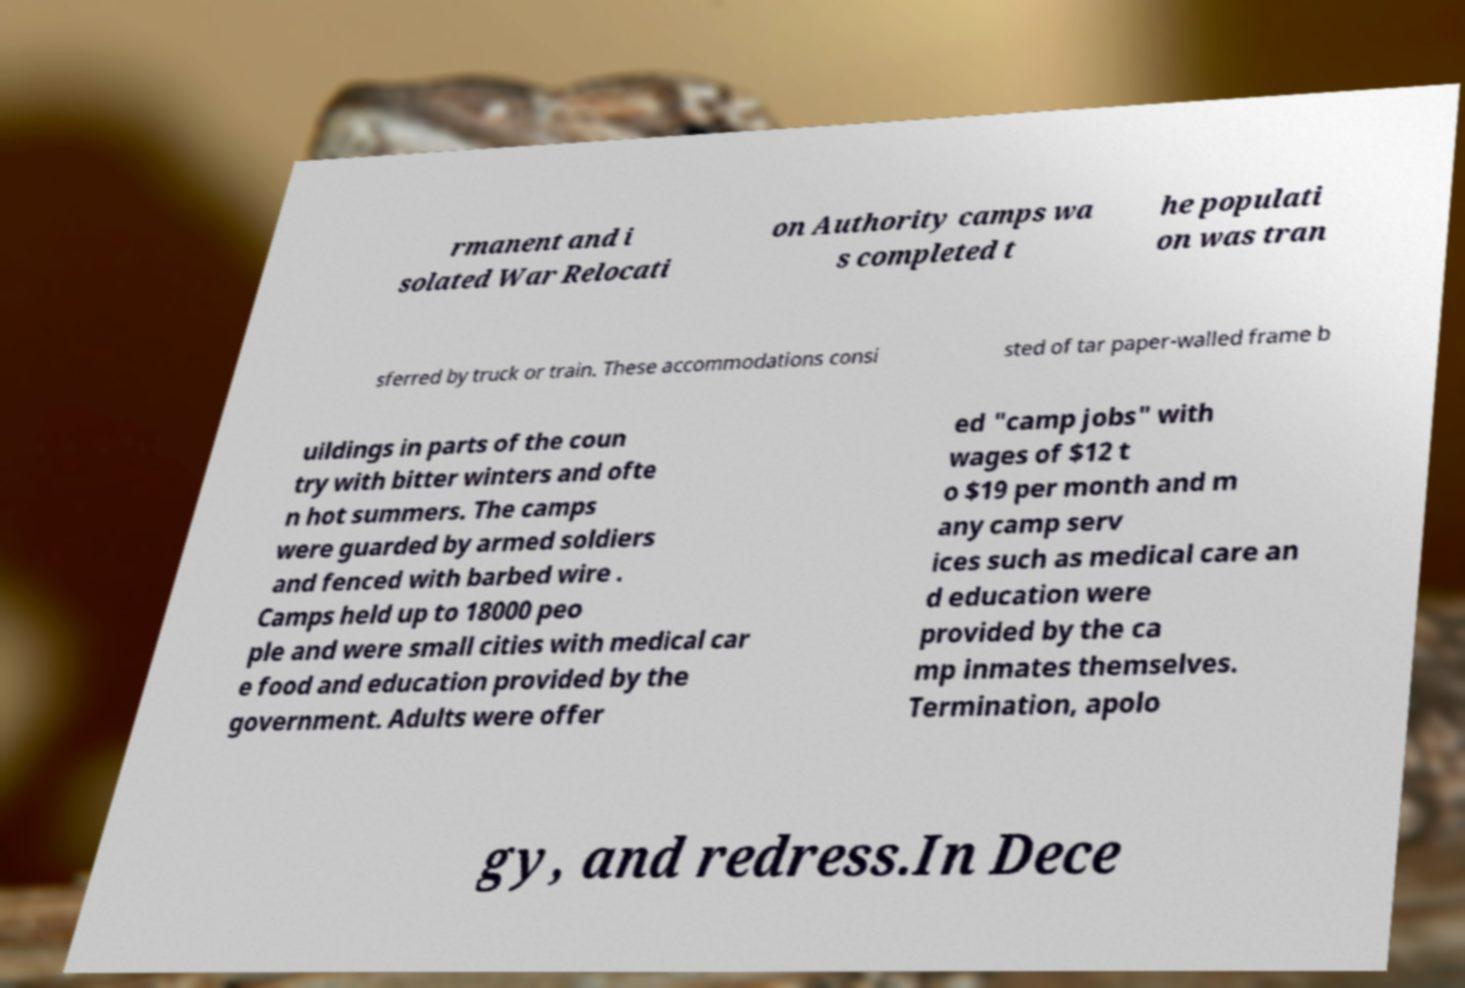Can you read and provide the text displayed in the image?This photo seems to have some interesting text. Can you extract and type it out for me? rmanent and i solated War Relocati on Authority camps wa s completed t he populati on was tran sferred by truck or train. These accommodations consi sted of tar paper-walled frame b uildings in parts of the coun try with bitter winters and ofte n hot summers. The camps were guarded by armed soldiers and fenced with barbed wire . Camps held up to 18000 peo ple and were small cities with medical car e food and education provided by the government. Adults were offer ed "camp jobs" with wages of $12 t o $19 per month and m any camp serv ices such as medical care an d education were provided by the ca mp inmates themselves. Termination, apolo gy, and redress.In Dece 